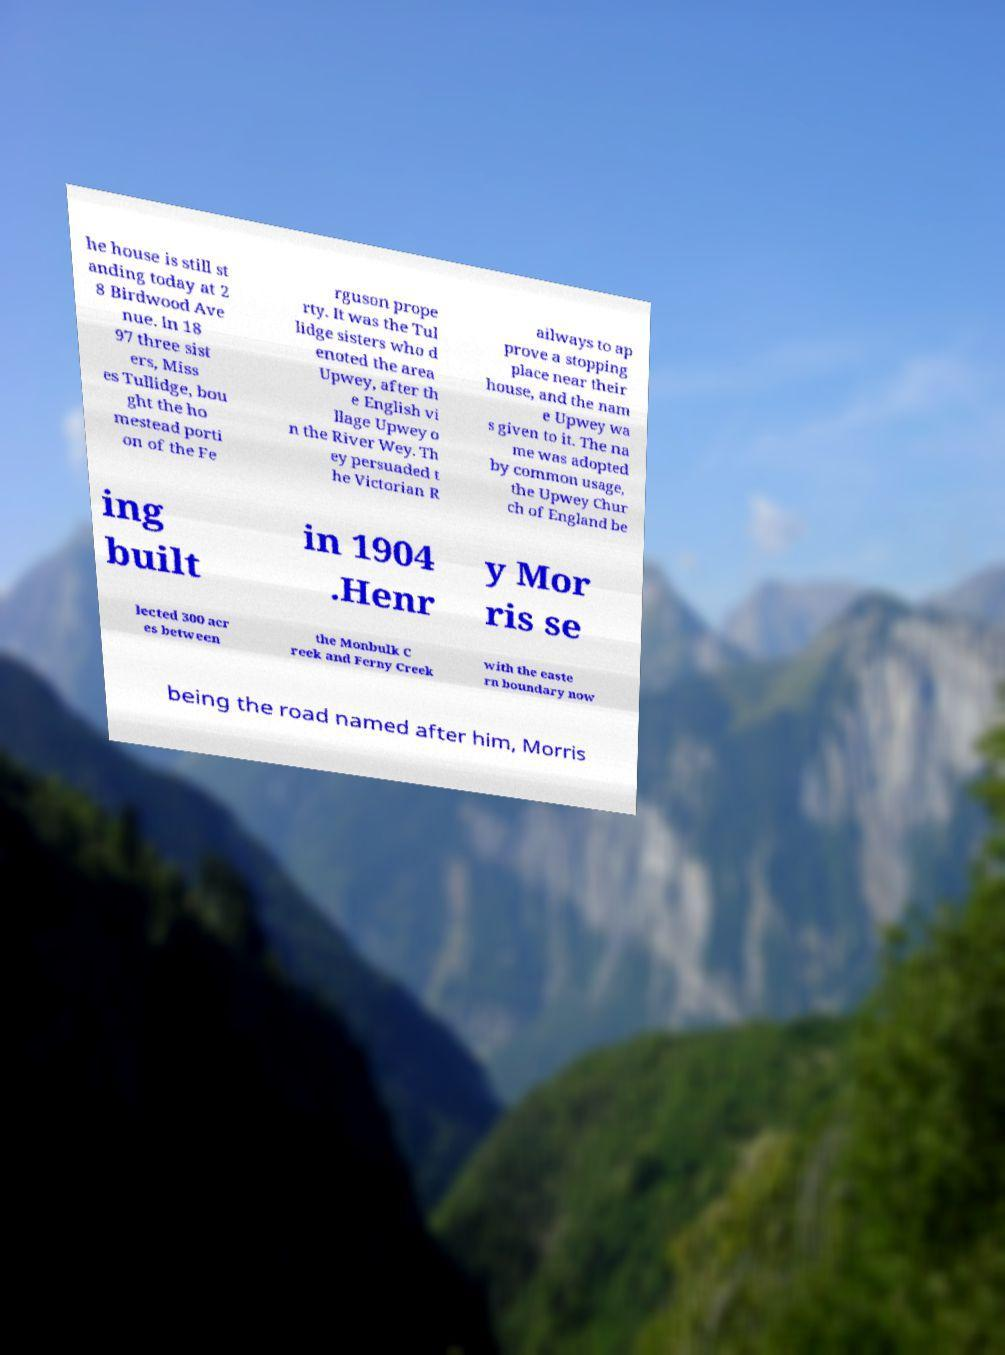Could you extract and type out the text from this image? he house is still st anding today at 2 8 Birdwood Ave nue. In 18 97 three sist ers, Miss es Tullidge, bou ght the ho mestead porti on of the Fe rguson prope rty. It was the Tul lidge sisters who d enoted the area Upwey, after th e English vi llage Upwey o n the River Wey. Th ey persuaded t he Victorian R ailways to ap prove a stopping place near their house, and the nam e Upwey wa s given to it. The na me was adopted by common usage, the Upwey Chur ch of England be ing built in 1904 .Henr y Mor ris se lected 300 acr es between the Monbulk C reek and Ferny Creek with the easte rn boundary now being the road named after him, Morris 